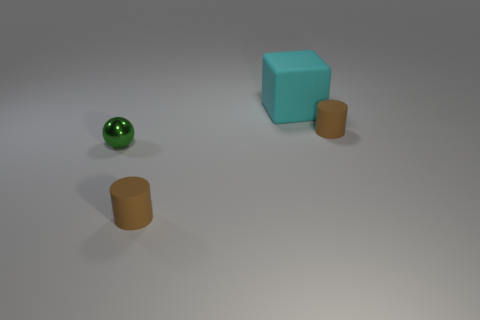Can you speculate on the purpose of these objects or their arrangement? The arrangement of objects doesn't seem to fulfill a practical function, suggesting it might be an abstract composition for aesthetic or illustrative purposes, perhaps to demonstrate concepts of geometry, light, and shadow in a 3D rendering context. 